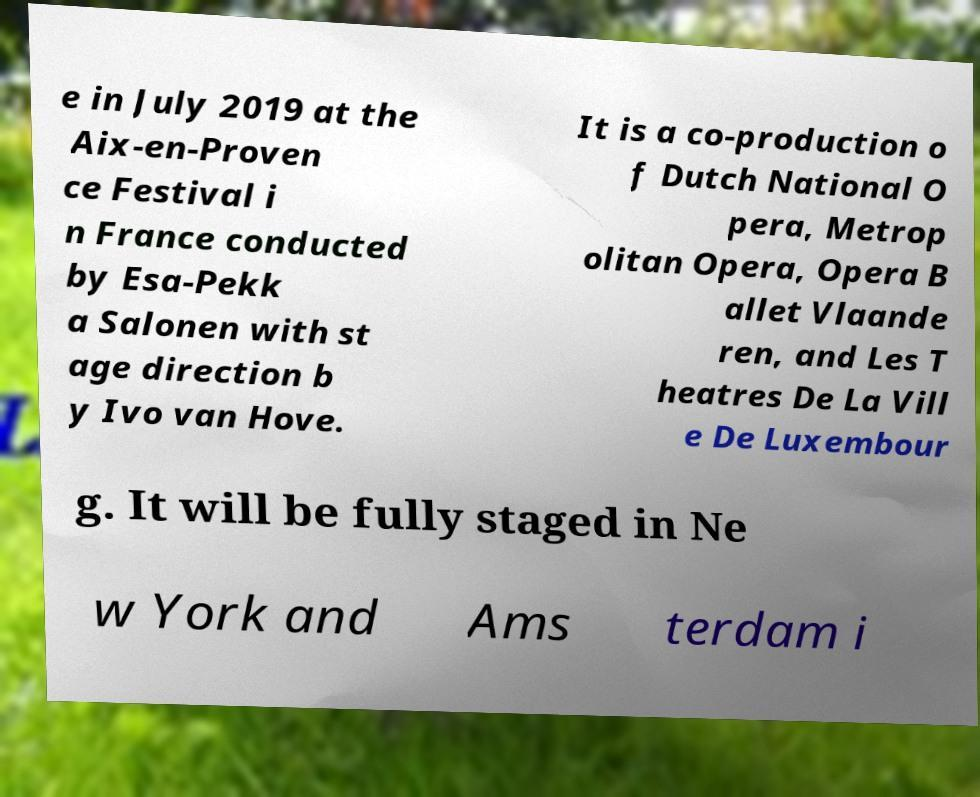Could you extract and type out the text from this image? e in July 2019 at the Aix-en-Proven ce Festival i n France conducted by Esa-Pekk a Salonen with st age direction b y Ivo van Hove. It is a co-production o f Dutch National O pera, Metrop olitan Opera, Opera B allet Vlaande ren, and Les T heatres De La Vill e De Luxembour g. It will be fully staged in Ne w York and Ams terdam i 